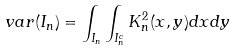<formula> <loc_0><loc_0><loc_500><loc_500>\ v a r ( I _ { n } ) = \int _ { I _ { n } } { \int _ { I _ { n } ^ { c } } { K _ { n } ^ { 2 } ( x , y ) d x } d y }</formula> 